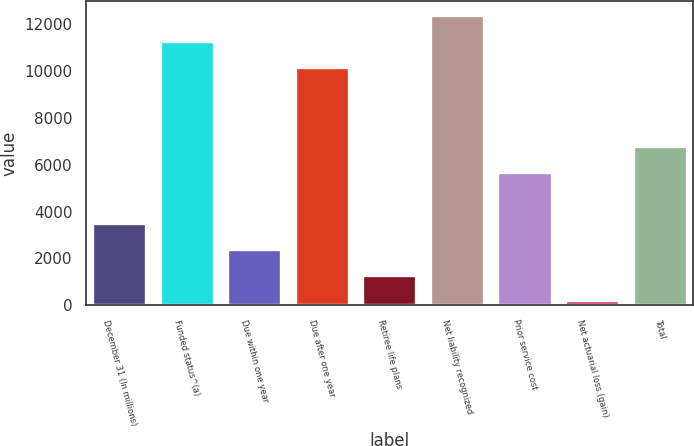<chart> <loc_0><loc_0><loc_500><loc_500><bar_chart><fcel>December 31 (In millions)<fcel>Funded status^(a)<fcel>Due within one year<fcel>Due after one year<fcel>Retiree life plans<fcel>Net liability recognized<fcel>Prior service cost<fcel>Net actuarial loss (gain)<fcel>Total<nl><fcel>3500.7<fcel>11268.9<fcel>2403.8<fcel>10172<fcel>1306.9<fcel>12365.8<fcel>5700<fcel>210<fcel>6796.9<nl></chart> 